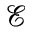<formula> <loc_0><loc_0><loc_500><loc_500>\mathcal { E }</formula> 